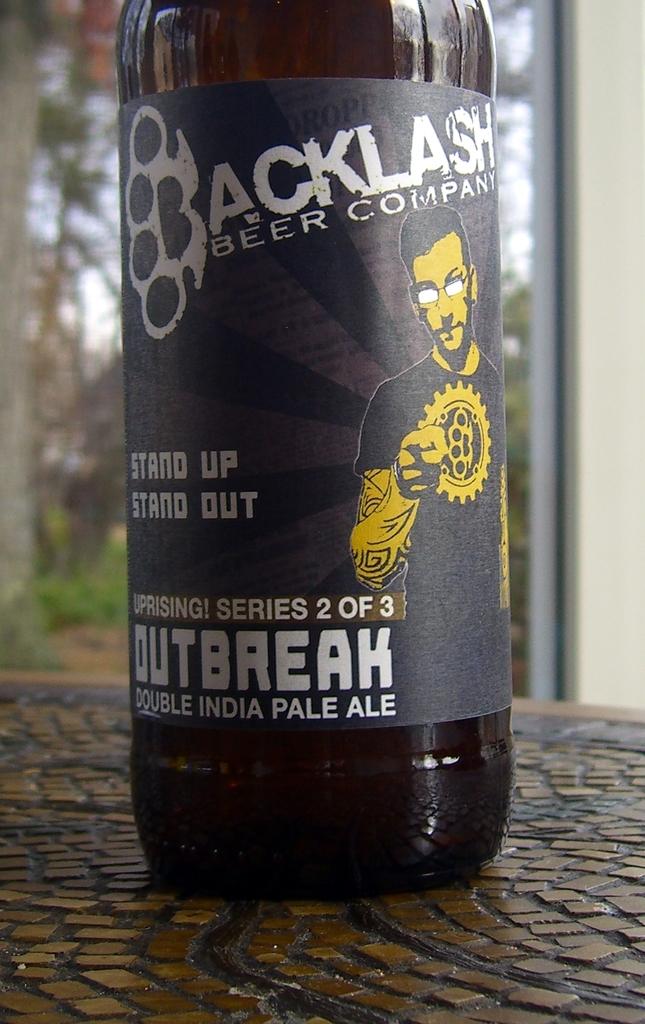What kind of beer is this?
Keep it short and to the point. Backlash. 